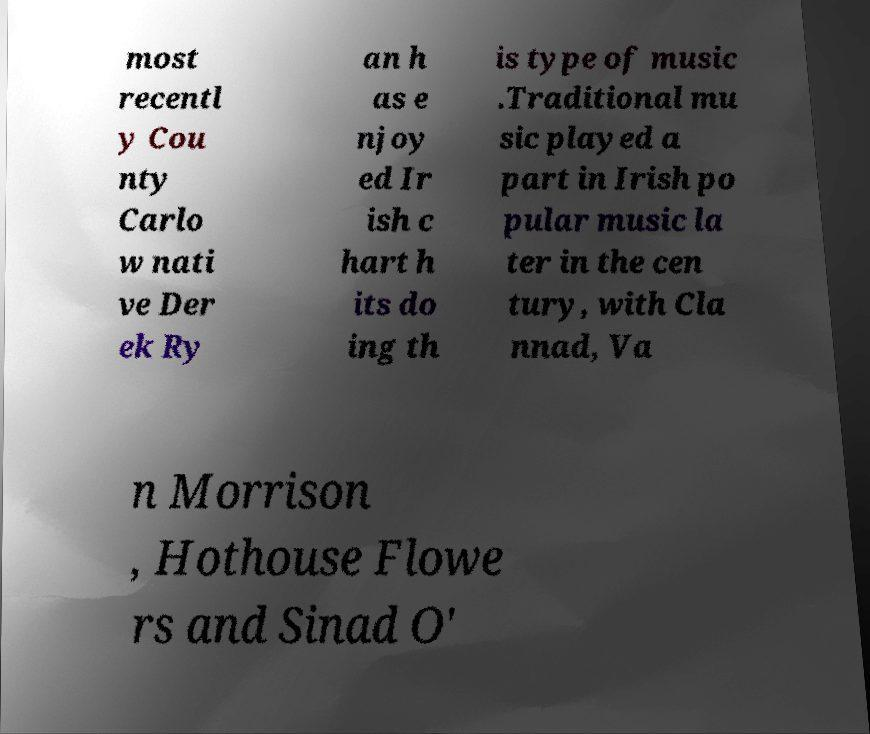Can you read and provide the text displayed in the image?This photo seems to have some interesting text. Can you extract and type it out for me? most recentl y Cou nty Carlo w nati ve Der ek Ry an h as e njoy ed Ir ish c hart h its do ing th is type of music .Traditional mu sic played a part in Irish po pular music la ter in the cen tury, with Cla nnad, Va n Morrison , Hothouse Flowe rs and Sinad O' 